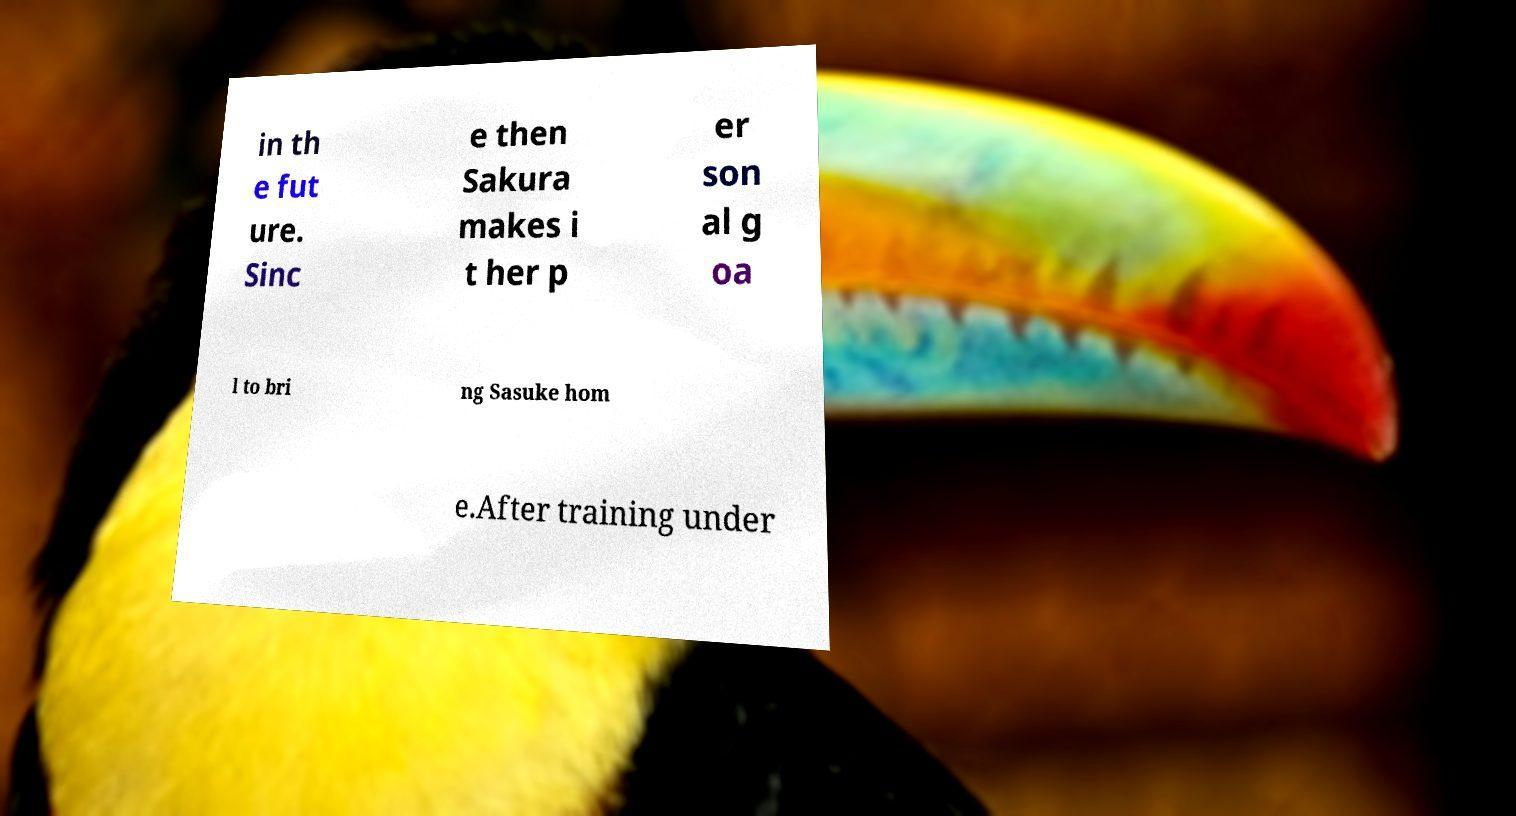Please read and relay the text visible in this image. What does it say? in th e fut ure. Sinc e then Sakura makes i t her p er son al g oa l to bri ng Sasuke hom e.After training under 